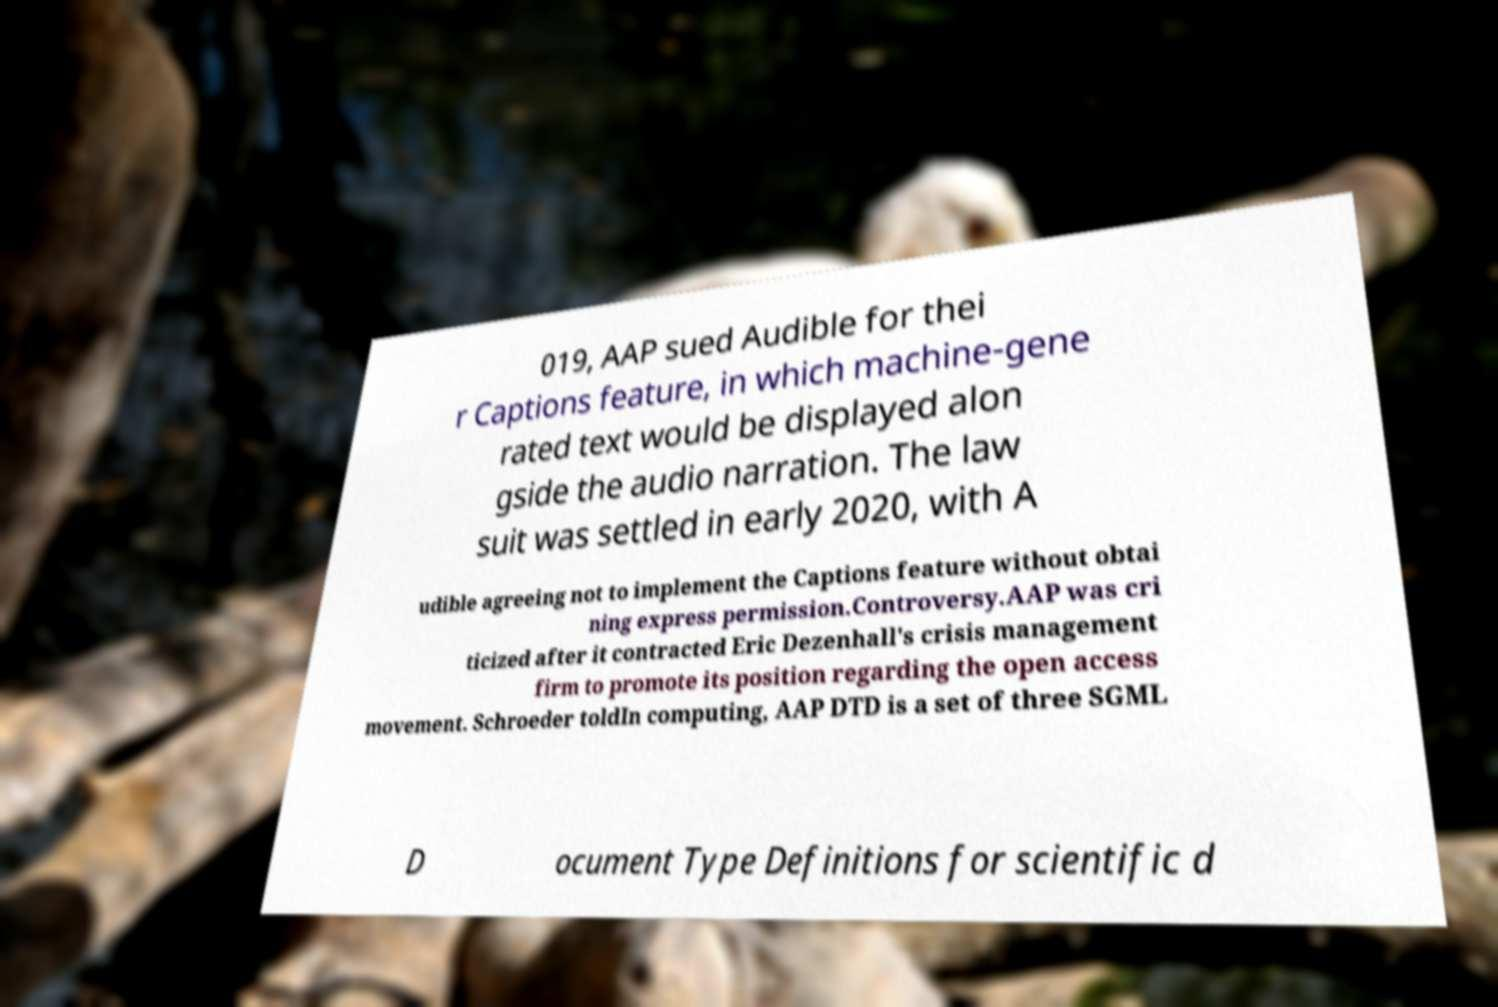I need the written content from this picture converted into text. Can you do that? 019, AAP sued Audible for thei r Captions feature, in which machine-gene rated text would be displayed alon gside the audio narration. The law suit was settled in early 2020, with A udible agreeing not to implement the Captions feature without obtai ning express permission.Controversy.AAP was cri ticized after it contracted Eric Dezenhall's crisis management firm to promote its position regarding the open access movement. Schroeder toldIn computing, AAP DTD is a set of three SGML D ocument Type Definitions for scientific d 